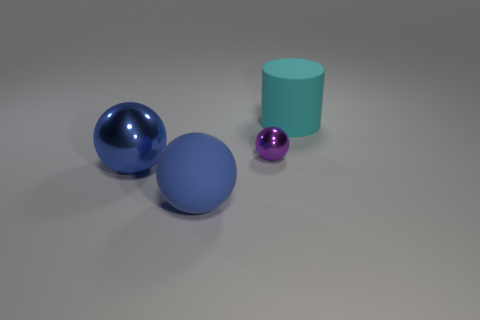Is the size of the cylinder the same as the purple shiny thing?
Provide a succinct answer. No. Is the size of the blue rubber sphere the same as the sphere right of the blue matte ball?
Offer a very short reply. No. What number of cylinders are large yellow objects or cyan things?
Make the answer very short. 1. What number of matte objects are the same color as the small sphere?
Keep it short and to the point. 0. How big is the thing that is both in front of the small sphere and behind the matte ball?
Your response must be concise. Large. Are there fewer blue balls that are left of the big metallic ball than shiny balls?
Provide a short and direct response. Yes. What number of objects are either cyan matte cylinders or matte spheres?
Your response must be concise. 2. How many tiny purple spheres are made of the same material as the purple thing?
Your answer should be very brief. 0. The other metallic thing that is the same shape as the large blue metal object is what size?
Provide a succinct answer. Small. Are there any large objects behind the purple ball?
Offer a terse response. Yes. 